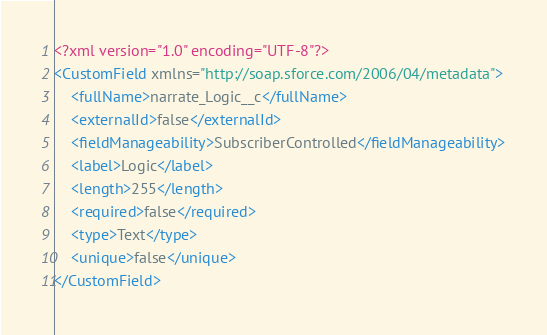Convert code to text. <code><loc_0><loc_0><loc_500><loc_500><_XML_><?xml version="1.0" encoding="UTF-8"?>
<CustomField xmlns="http://soap.sforce.com/2006/04/metadata">
    <fullName>narrate_Logic__c</fullName>
    <externalId>false</externalId>
    <fieldManageability>SubscriberControlled</fieldManageability>
    <label>Logic</label>
    <length>255</length>
    <required>false</required>
    <type>Text</type>
    <unique>false</unique>
</CustomField>
</code> 